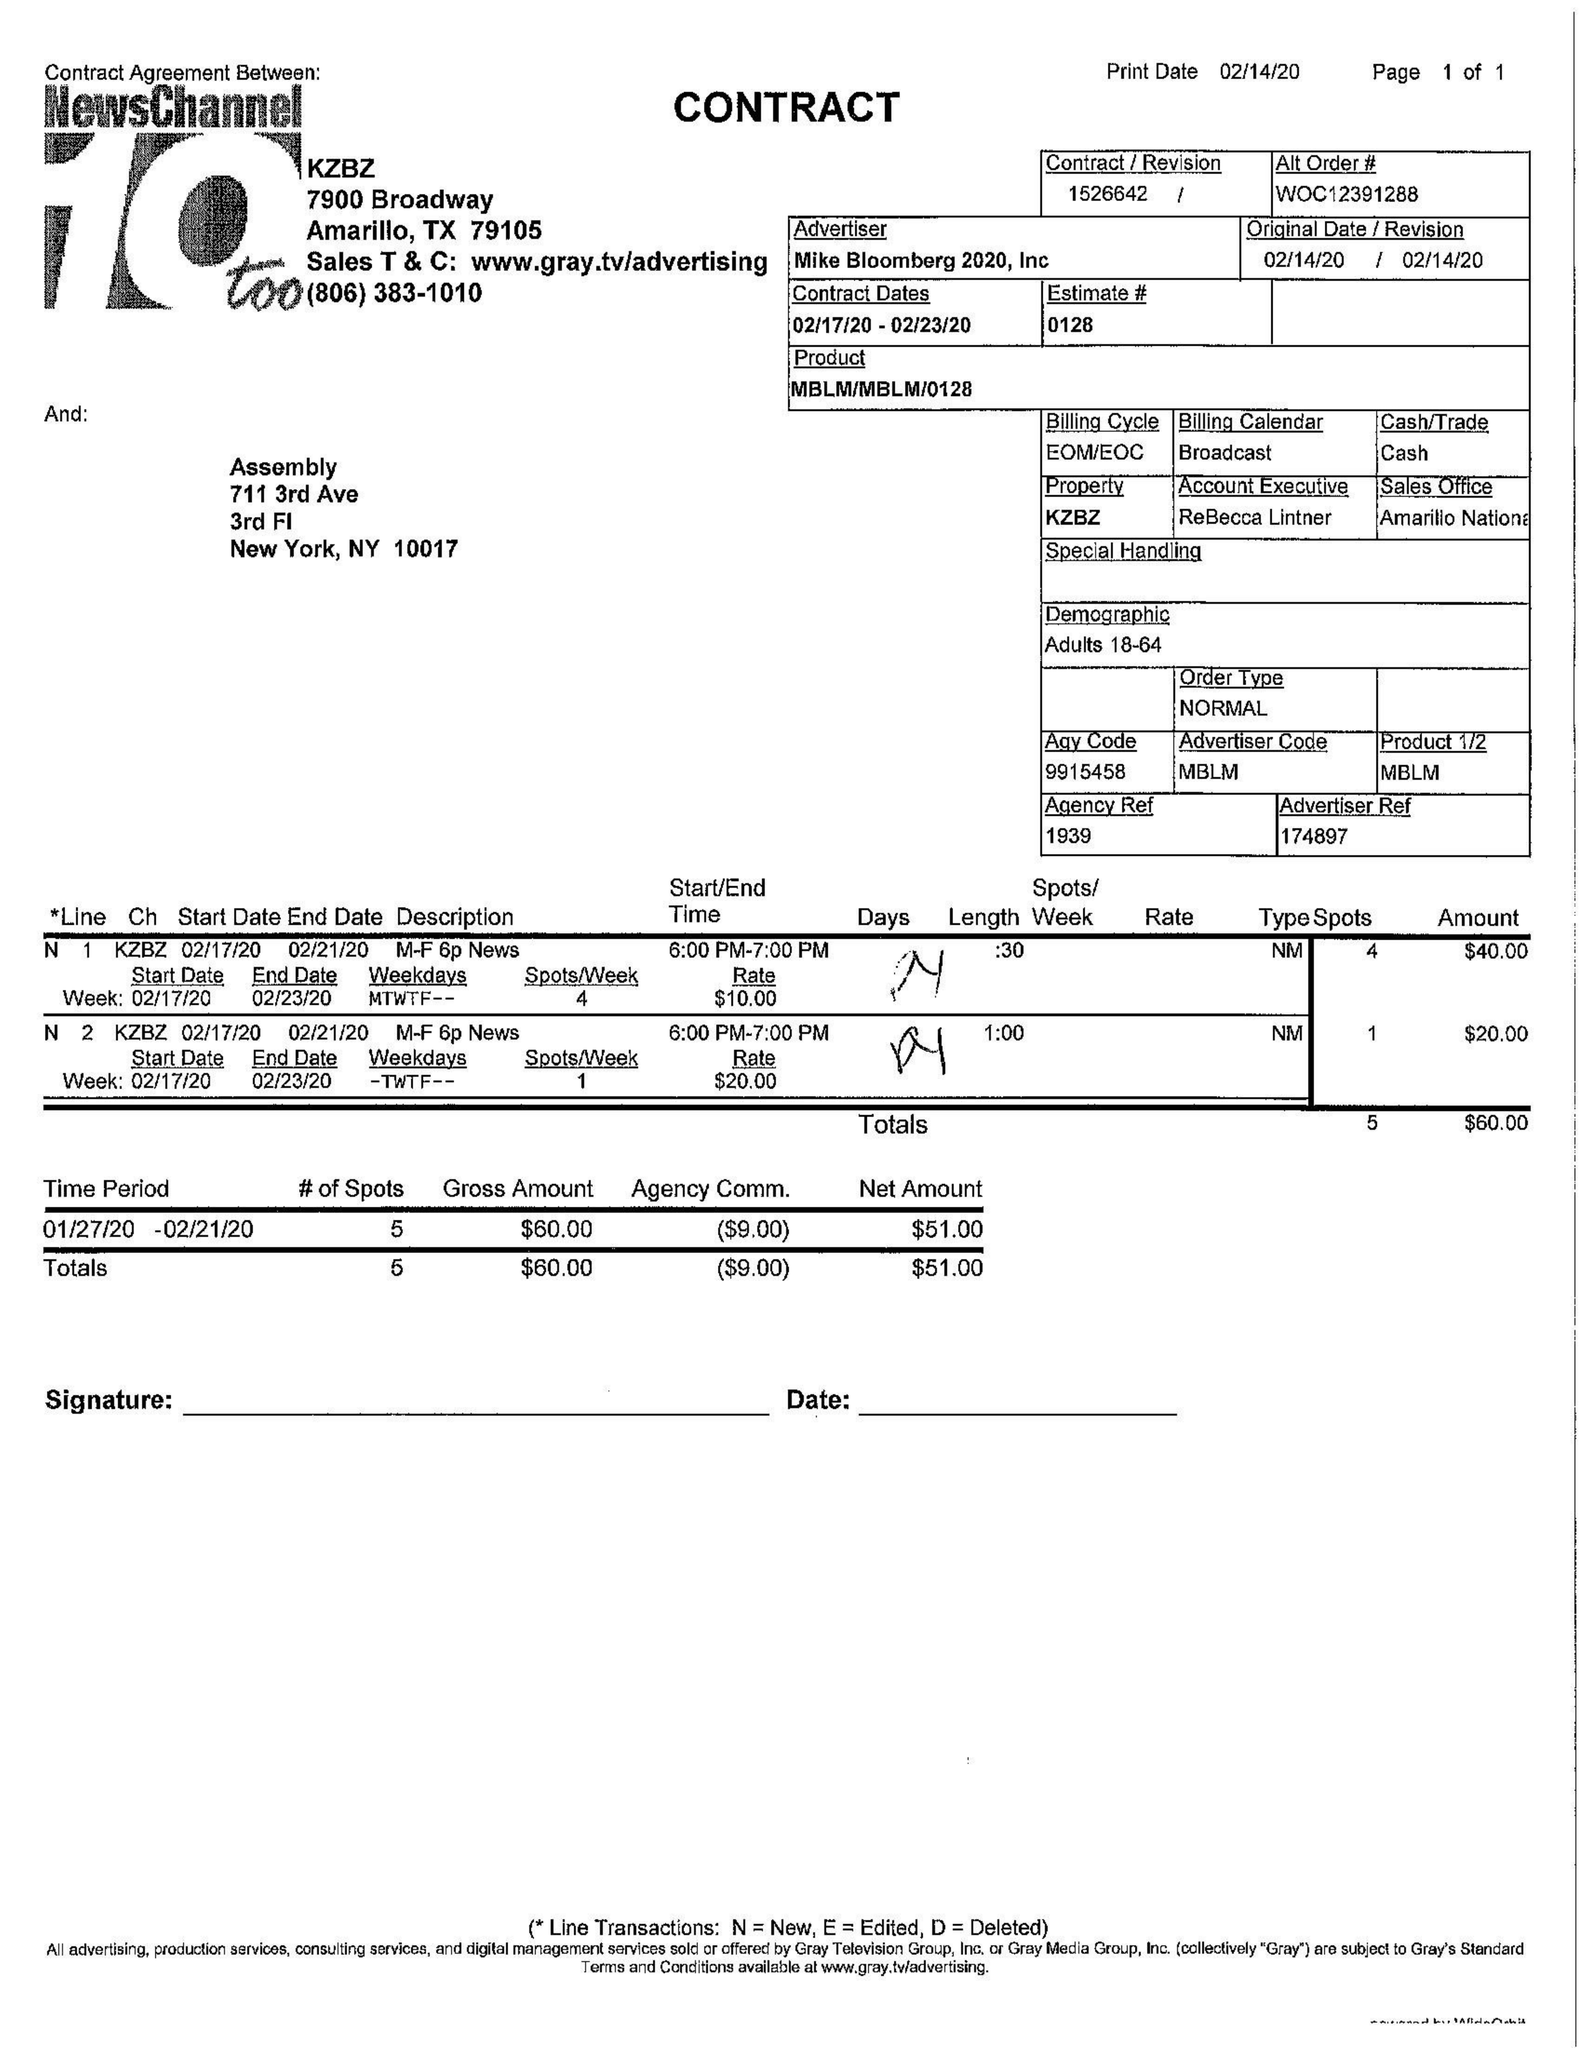What is the value for the flight_from?
Answer the question using a single word or phrase. 02/17/20 